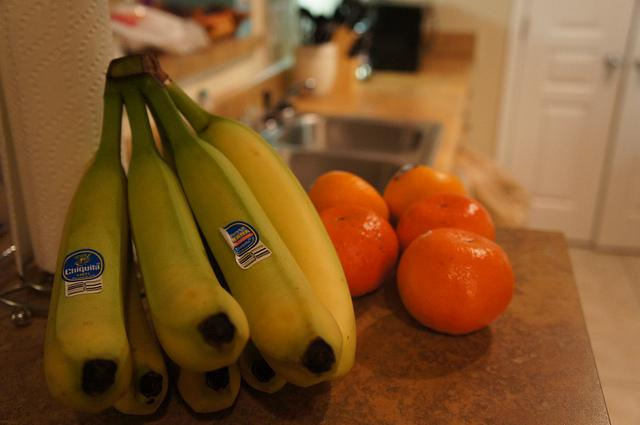What is next to the banana? Please explain your reasoning. orange. The fruit next the banana is orange and round in color. 